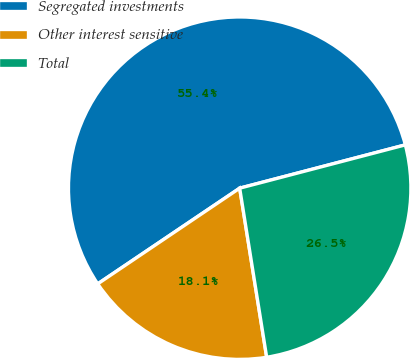Convert chart to OTSL. <chart><loc_0><loc_0><loc_500><loc_500><pie_chart><fcel>Segregated investments<fcel>Other interest sensitive<fcel>Total<nl><fcel>55.37%<fcel>18.08%<fcel>26.55%<nl></chart> 